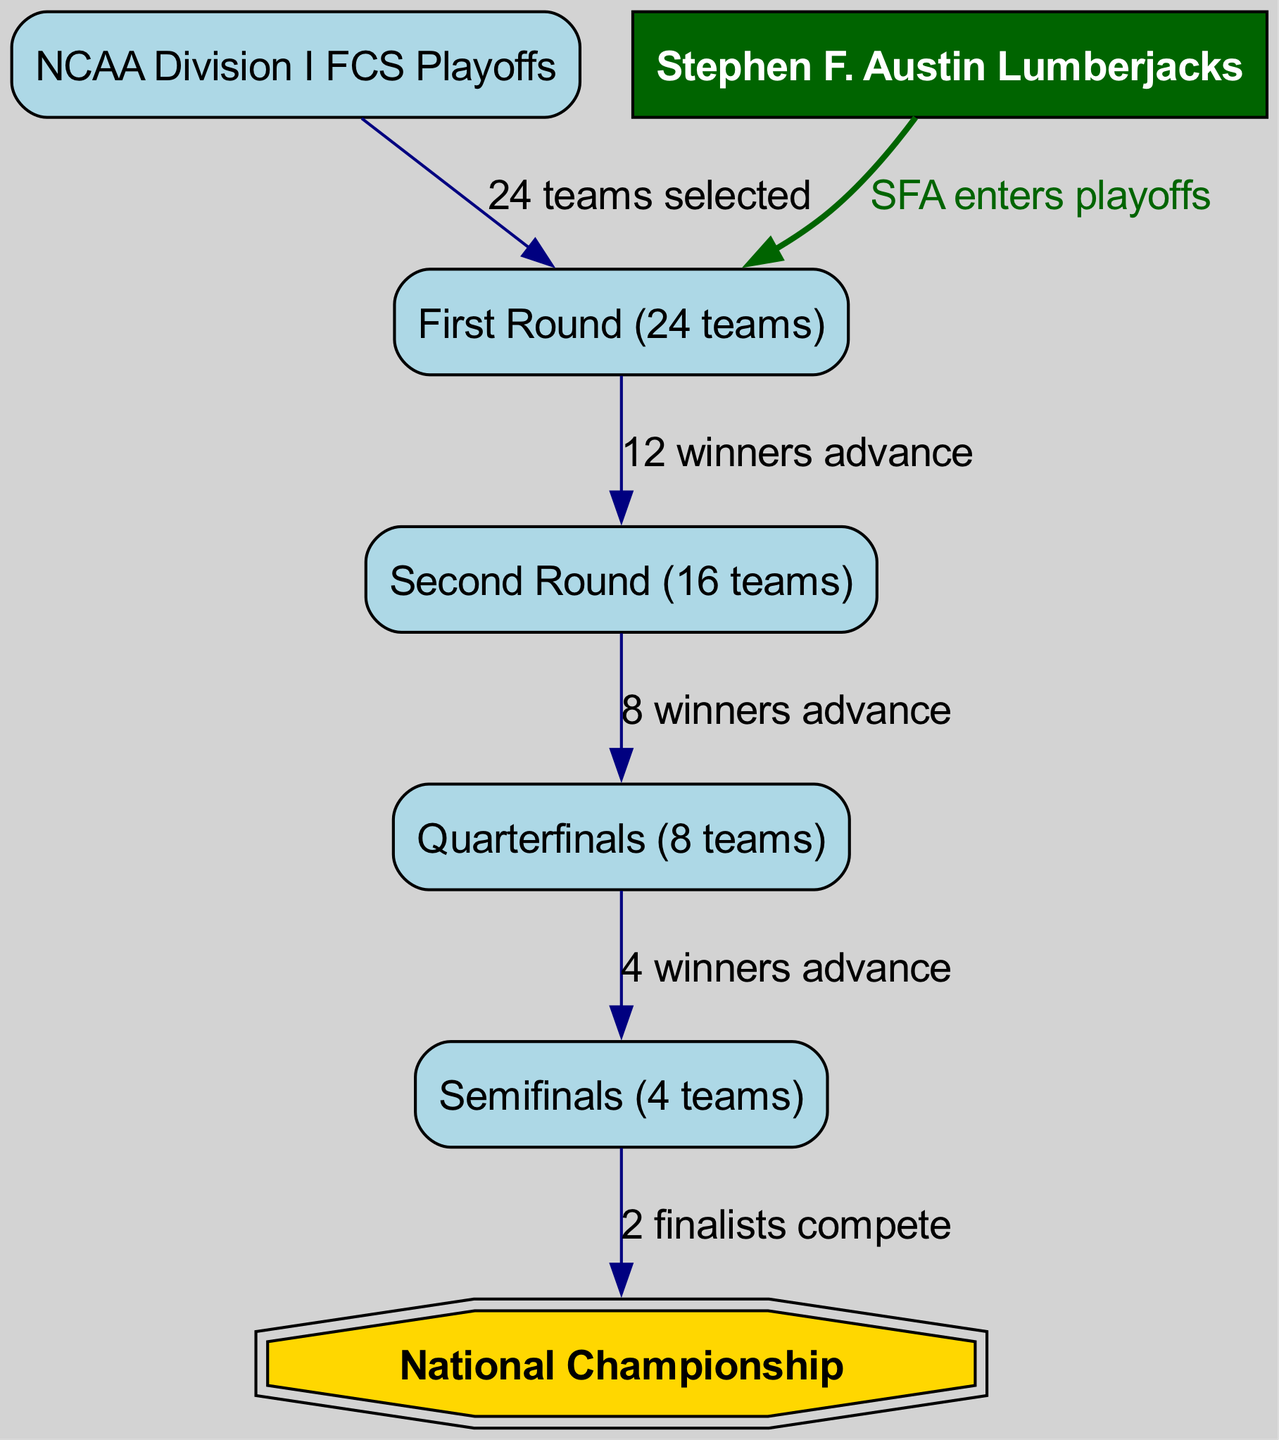What is the total number of teams in the first round? The diagram indicates that there are 24 teams selected for the first round. This information is explicitly stated in the "First Round (24 teams)" node in the diagram.
Answer: 24 teams What does SFA stand for in this diagram? Based on the context provided in the diagram, "SFA" refers to the "Stephen F. Austin Lumberjacks." This is evident from the node labeled "Stephen F. Austin Lumberjacks" in the diagram.
Answer: Stephen F. Austin Lumberjacks How many teams advance from the semifinals to the championship? Referring to the edges in the diagram, it shows that 2 finalists compete in the championship, indicating that only two teams advance from the semifinals.
Answer: 2 teams What is the final stage of the NCAA Division I FCS Playoffs? The diagram shows that the ultimate goal of the playoff structure is the "National Championship," which is the last node in the flow.
Answer: National Championship How many rounds are there before reaching the championship? By analyzing the diagram, there are a total of four rounds before the championship: First Round, Second Round, Quarterfinals, and Semifinals. Summing these rounds leads to the answer.
Answer: 4 rounds What color represents the Stephen F. Austin Lumberjacks in the diagram? The diagram specifies that the SFA node is filled with dark green color, as indicated by its styling properties in the code section of the image generation instructions.
Answer: Dark green What is the relationship between the first round and the second round? The diagram shows the edge labeled "12 winners advance," indicating that the connection between these two rounds is that twelve teams from the first round progress to the second round.
Answer: 12 winners advance Which node indicates the entry of SFA into the playoffs? The edge labeled "SFA enters playoffs" directly connects the SFA node to the first-round node, highlighting the entry point for the Lumberjacks in the playoff structure.
Answer: First Round 